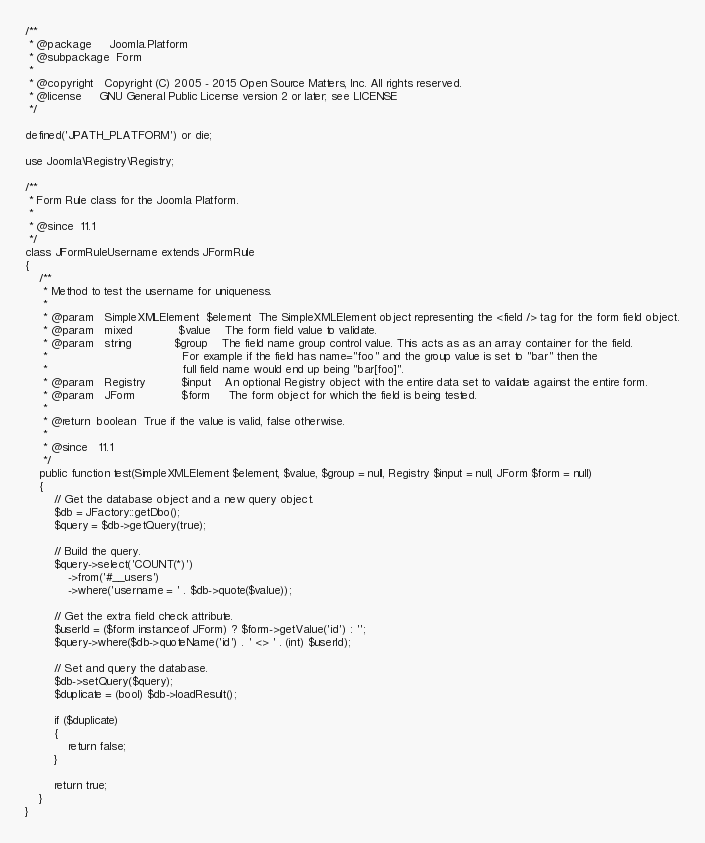<code> <loc_0><loc_0><loc_500><loc_500><_PHP_>/**
 * @package     Joomla.Platform
 * @subpackage  Form
 *
 * @copyright   Copyright (C) 2005 - 2015 Open Source Matters, Inc. All rights reserved.
 * @license     GNU General Public License version 2 or later; see LICENSE
 */

defined('JPATH_PLATFORM') or die;

use Joomla\Registry\Registry;

/**
 * Form Rule class for the Joomla Platform.
 *
 * @since  11.1
 */
class JFormRuleUsername extends JFormRule
{
	/**
	 * Method to test the username for uniqueness.
	 *
	 * @param   SimpleXMLElement  $element  The SimpleXMLElement object representing the <field /> tag for the form field object.
	 * @param   mixed             $value    The form field value to validate.
	 * @param   string            $group    The field name group control value. This acts as as an array container for the field.
	 *                                      For example if the field has name="foo" and the group value is set to "bar" then the
	 *                                      full field name would end up being "bar[foo]".
	 * @param   Registry          $input    An optional Registry object with the entire data set to validate against the entire form.
	 * @param   JForm             $form     The form object for which the field is being tested.
	 *
	 * @return  boolean  True if the value is valid, false otherwise.
	 *
	 * @since   11.1
	 */
	public function test(SimpleXMLElement $element, $value, $group = null, Registry $input = null, JForm $form = null)
	{
		// Get the database object and a new query object.
		$db = JFactory::getDbo();
		$query = $db->getQuery(true);

		// Build the query.
		$query->select('COUNT(*)')
			->from('#__users')
			->where('username = ' . $db->quote($value));

		// Get the extra field check attribute.
		$userId = ($form instanceof JForm) ? $form->getValue('id') : '';
		$query->where($db->quoteName('id') . ' <> ' . (int) $userId);

		// Set and query the database.
		$db->setQuery($query);
		$duplicate = (bool) $db->loadResult();

		if ($duplicate)
		{
			return false;
		}

		return true;
	}
}
</code> 